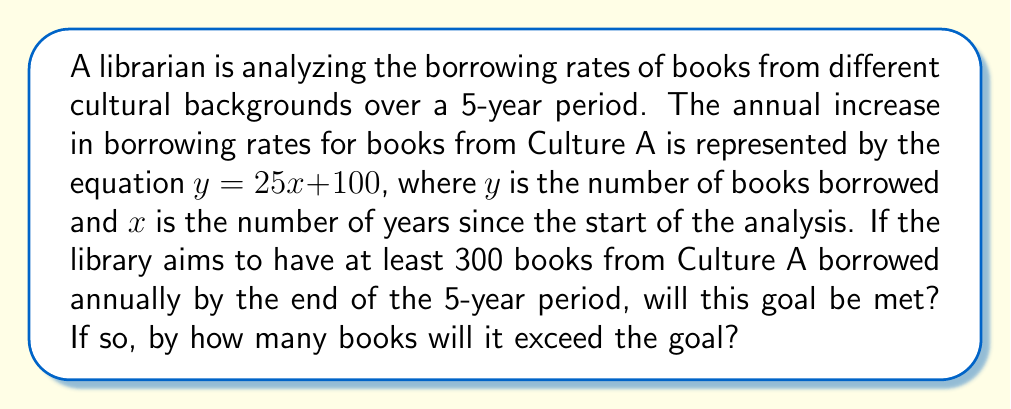Teach me how to tackle this problem. To solve this problem, we'll follow these steps:

1) The equation given is $y = 25x + 100$, where:
   $y$ = number of books borrowed
   $x$ = number of years since the start
   $100$ = initial number of books borrowed
   $25$ = annual increase in borrowing

2) We need to find $y$ when $x = 5$ (end of 5-year period):

   $y = 25(5) + 100$
   $y = 125 + 100$
   $y = 225$

3) The goal is to have at least 300 books borrowed annually.

4) Compare the result with the goal:
   $225 < 300$

5) Calculate the difference:
   $300 - 225 = 75$

Therefore, the goal will not be met. The borrowing rate will be 75 books short of the 300-book goal by the end of the 5-year period.
Answer: No, 75 books short 